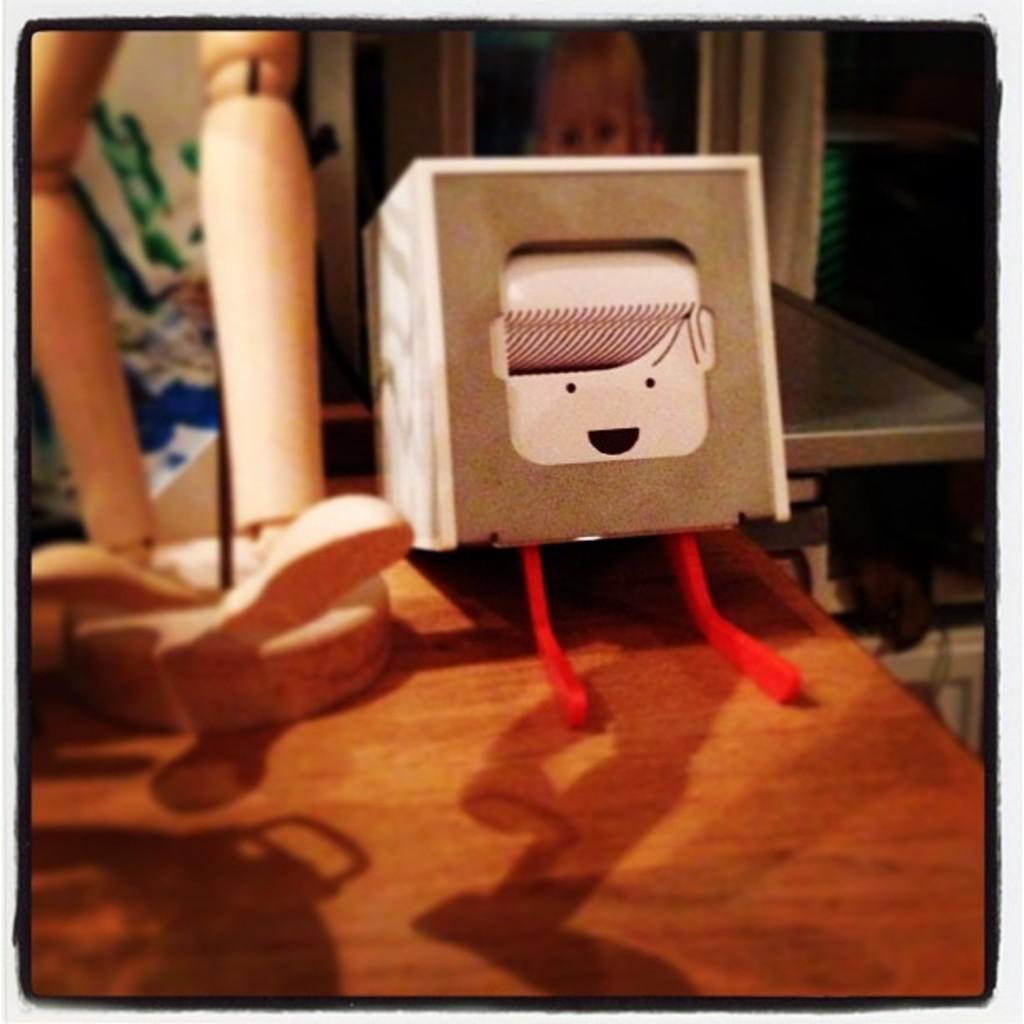What is on the wooden table in the image? There are toys and other objects on the wooden table in the image. Can you describe the photo in the background of the image? There is a photo of a person in the background of the image, and it is likely displayed in a frame or similar item. What type of alley can be seen behind the toys on the wooden table? There is no alley present in the image; it features a wooden table with toys and other objects, as well as a photo in the background. 